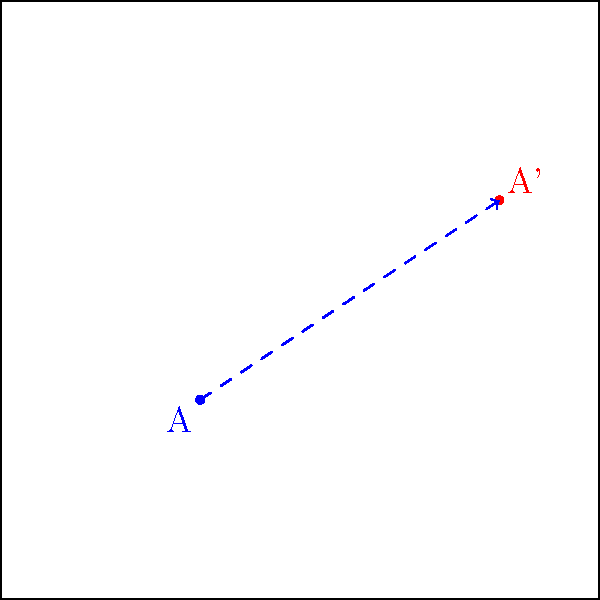In a Cordova app, you need to translate a button from point A(1,1) to point A'(4,3) on the screen. What is the translation vector $\vec{v}$ required for this transformation? To find the translation vector $\vec{v}$, we need to follow these steps:

1. Identify the initial position: A(1,1)
2. Identify the final position: A'(4,3)
3. Calculate the displacement in x and y directions:
   - x displacement: $4 - 1 = 3$
   - y displacement: $3 - 1 = 2$
4. Express the translation vector as $\vec{v} = (x_{displacement}, y_{displacement})$

Therefore, the translation vector $\vec{v}$ is $(3, 2)$. This means the button needs to be moved 3 units in the positive x-direction and 2 units in the positive y-direction.

In Cordova, you would apply this translation using CSS transforms or by updating the button's position dynamically using JavaScript, depending on your implementation approach.
Answer: $\vec{v} = (3, 2)$ 